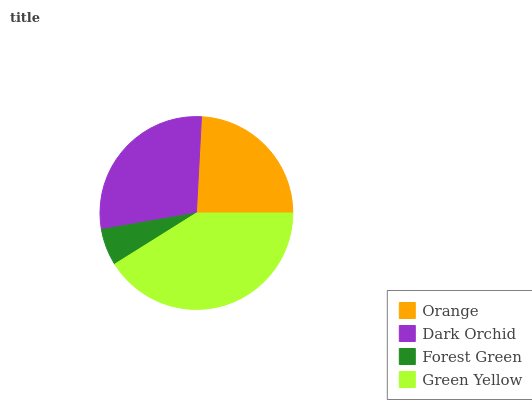Is Forest Green the minimum?
Answer yes or no. Yes. Is Green Yellow the maximum?
Answer yes or no. Yes. Is Dark Orchid the minimum?
Answer yes or no. No. Is Dark Orchid the maximum?
Answer yes or no. No. Is Dark Orchid greater than Orange?
Answer yes or no. Yes. Is Orange less than Dark Orchid?
Answer yes or no. Yes. Is Orange greater than Dark Orchid?
Answer yes or no. No. Is Dark Orchid less than Orange?
Answer yes or no. No. Is Dark Orchid the high median?
Answer yes or no. Yes. Is Orange the low median?
Answer yes or no. Yes. Is Orange the high median?
Answer yes or no. No. Is Dark Orchid the low median?
Answer yes or no. No. 